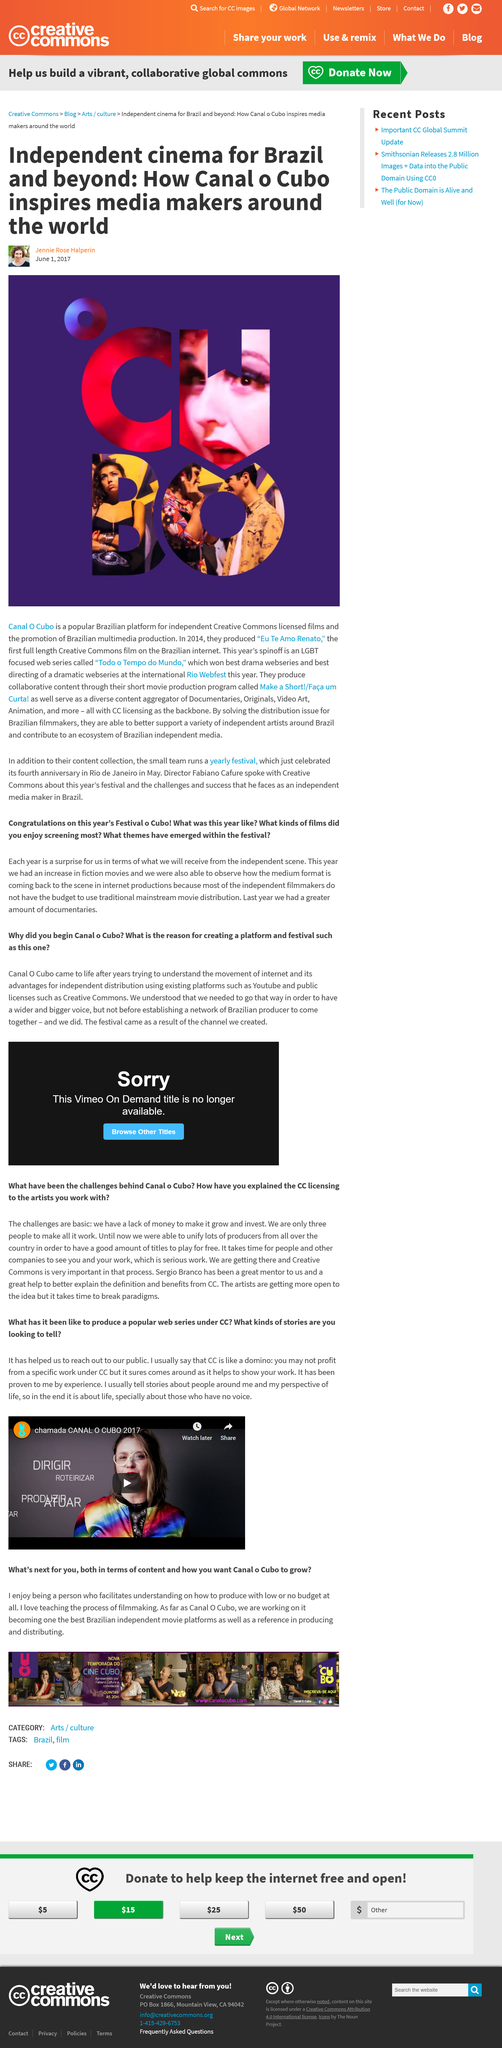List a handful of essential elements in this visual. This year's film festival featured an increase in the number of fiction films. Canal O Cubo won the award for best drama webseries and best directing of a dramatic webseries for their series Todo o Tempo do Mundo at the prestigious awards ceremony. Canal O Cubo is a film platform that is located in Brazil, and it provides a platform for the screening and promotion of various films. Festival o Cubo is a film festival. They won two awards for their LGBT web series at the Rio Webfest in 2017. 